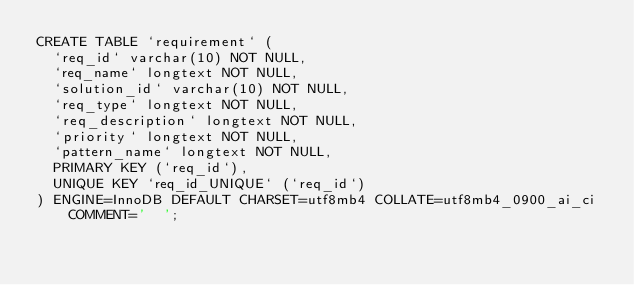<code> <loc_0><loc_0><loc_500><loc_500><_SQL_>CREATE TABLE `requirement` (
  `req_id` varchar(10) NOT NULL,
  `req_name` longtext NOT NULL,
  `solution_id` varchar(10) NOT NULL,
  `req_type` longtext NOT NULL,
  `req_description` longtext NOT NULL,
  `priority` longtext NOT NULL,
  `pattern_name` longtext NOT NULL,
  PRIMARY KEY (`req_id`),
  UNIQUE KEY `req_id_UNIQUE` (`req_id`)
) ENGINE=InnoDB DEFAULT CHARSET=utf8mb4 COLLATE=utf8mb4_0900_ai_ci COMMENT='	';
</code> 